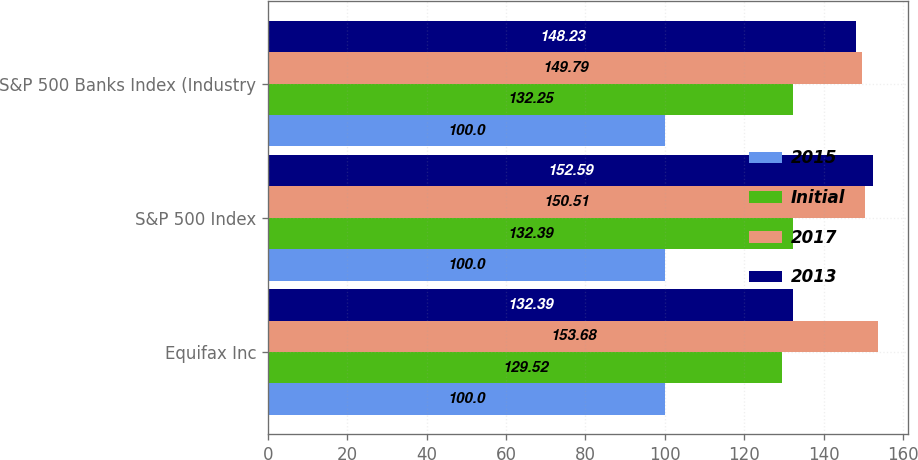<chart> <loc_0><loc_0><loc_500><loc_500><stacked_bar_chart><ecel><fcel>Equifax Inc<fcel>S&P 500 Index<fcel>S&P 500 Banks Index (Industry<nl><fcel>2015<fcel>100<fcel>100<fcel>100<nl><fcel>Initial<fcel>129.52<fcel>132.39<fcel>132.25<nl><fcel>2017<fcel>153.68<fcel>150.51<fcel>149.79<nl><fcel>2013<fcel>132.39<fcel>152.59<fcel>148.23<nl></chart> 